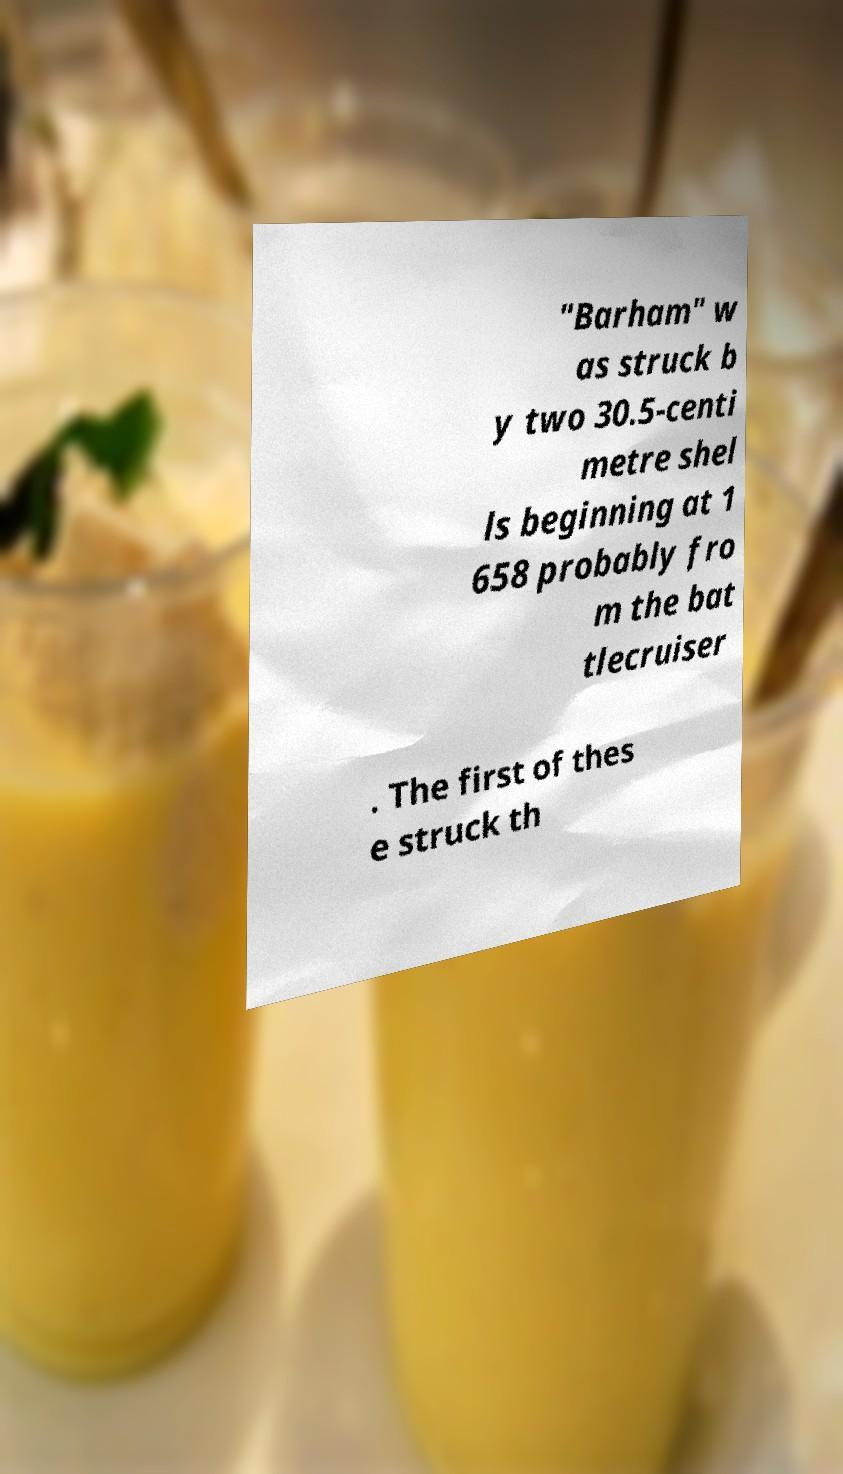Could you extract and type out the text from this image? "Barham" w as struck b y two 30.5-centi metre shel ls beginning at 1 658 probably fro m the bat tlecruiser . The first of thes e struck th 